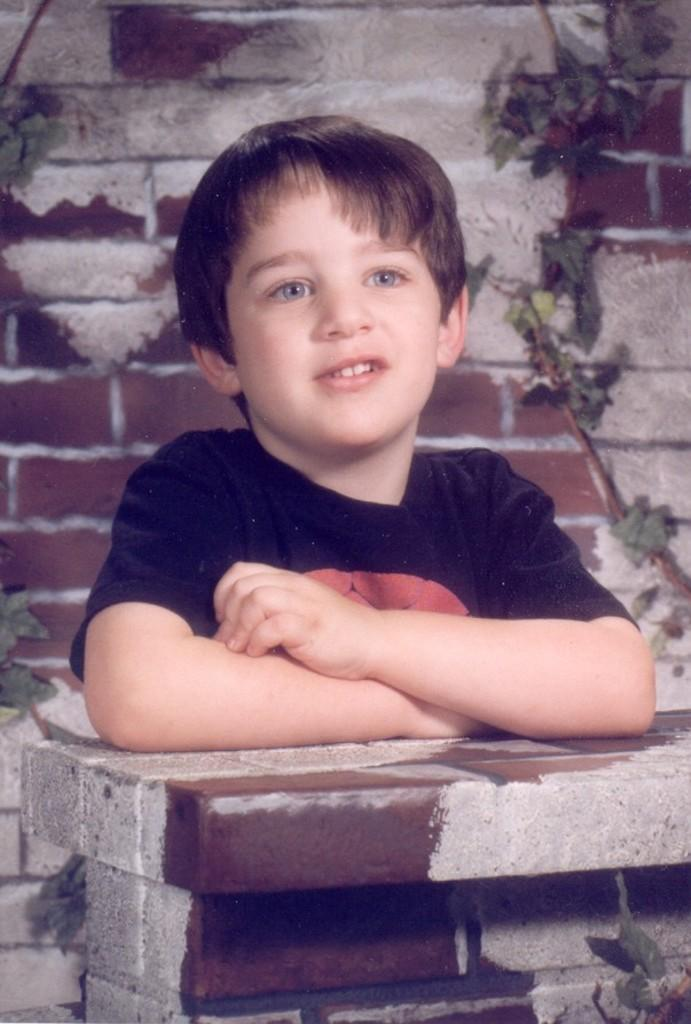Who is present in the image? There is a boy in the image. What is the boy's facial expression? The boy is smiling. What can be seen in the background of the image? There is a wall and plants in the background of the image. What type of debt is the boy discussing with the plants in the image? There is no mention of debt or any discussion in the image, as it features a boy smiling with a wall and plants in the background. 